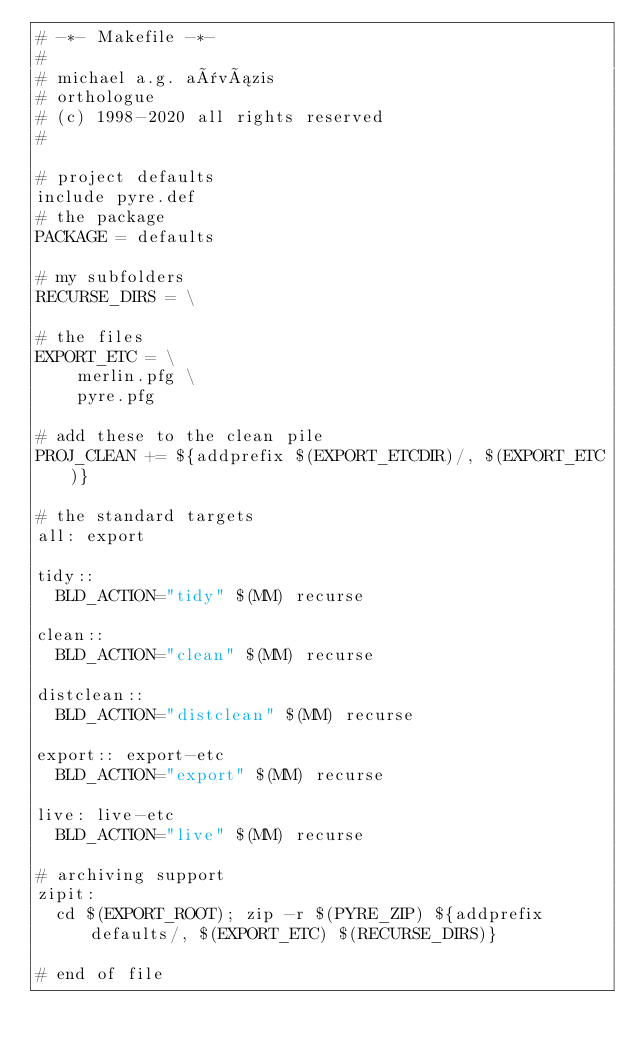<code> <loc_0><loc_0><loc_500><loc_500><_ObjectiveC_># -*- Makefile -*-
#
# michael a.g. aïvázis
# orthologue
# (c) 1998-2020 all rights reserved
#

# project defaults
include pyre.def
# the package
PACKAGE = defaults

# my subfolders
RECURSE_DIRS = \

# the files
EXPORT_ETC = \
    merlin.pfg \
    pyre.pfg

# add these to the clean pile
PROJ_CLEAN += ${addprefix $(EXPORT_ETCDIR)/, $(EXPORT_ETC)}

# the standard targets
all: export

tidy::
	BLD_ACTION="tidy" $(MM) recurse

clean::
	BLD_ACTION="clean" $(MM) recurse

distclean::
	BLD_ACTION="distclean" $(MM) recurse

export:: export-etc
	BLD_ACTION="export" $(MM) recurse

live: live-etc
	BLD_ACTION="live" $(MM) recurse

# archiving support
zipit:
	cd $(EXPORT_ROOT); zip -r $(PYRE_ZIP) ${addprefix defaults/, $(EXPORT_ETC) $(RECURSE_DIRS)}

# end of file
</code> 